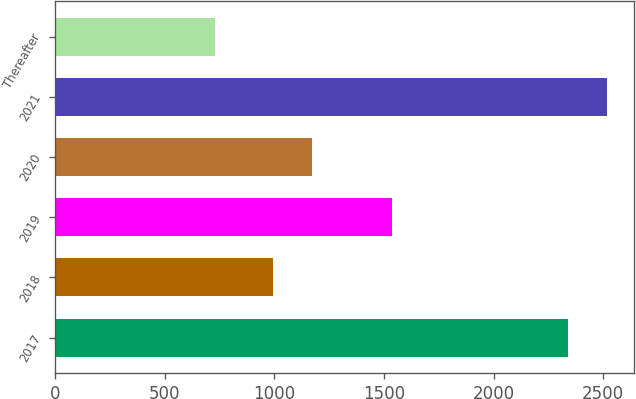Convert chart to OTSL. <chart><loc_0><loc_0><loc_500><loc_500><bar_chart><fcel>2017<fcel>2018<fcel>2019<fcel>2020<fcel>2021<fcel>Thereafter<nl><fcel>2340<fcel>995<fcel>1535<fcel>1171.7<fcel>2516.7<fcel>729<nl></chart> 